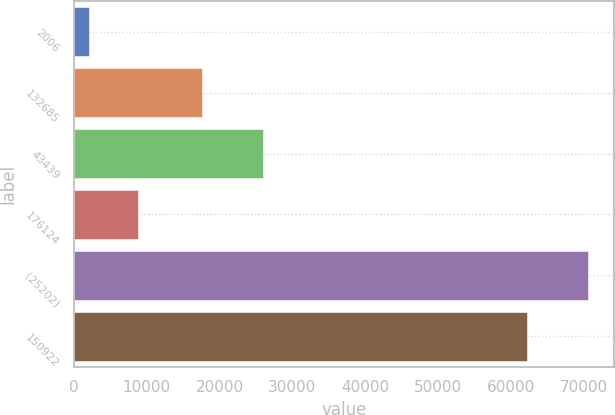Convert chart to OTSL. <chart><loc_0><loc_0><loc_500><loc_500><bar_chart><fcel>2006<fcel>132685<fcel>43439<fcel>176124<fcel>(25202)<fcel>150922<nl><fcel>2005<fcel>17592<fcel>25919<fcel>8862.6<fcel>70581<fcel>62254<nl></chart> 